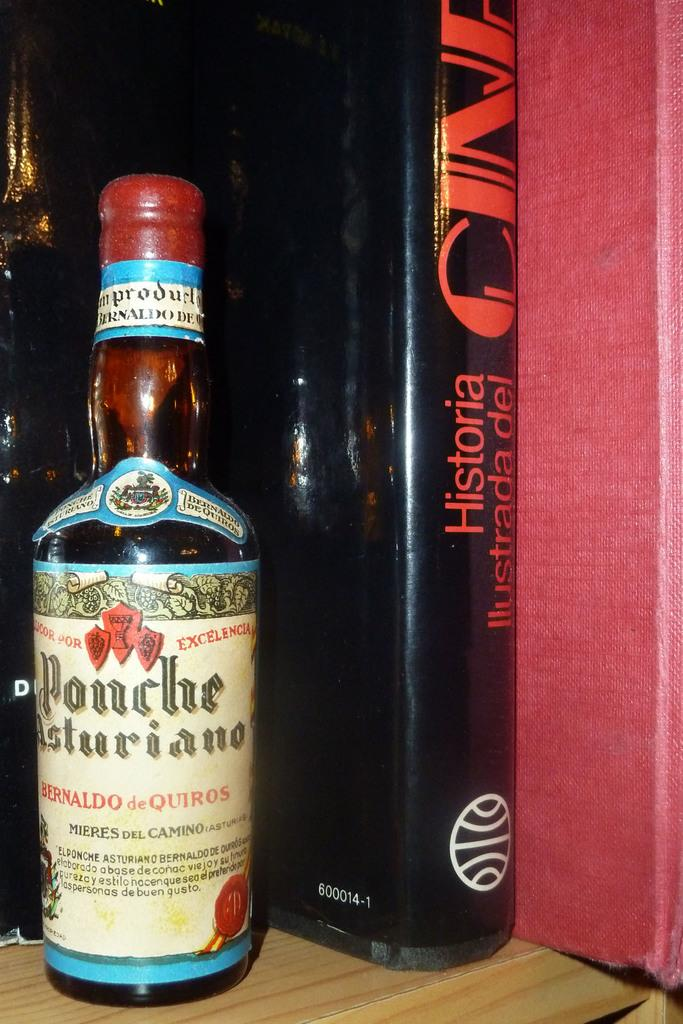<image>
Present a compact description of the photo's key features. a Ponche Asturiano liqior bottle on the shelf with a book. 